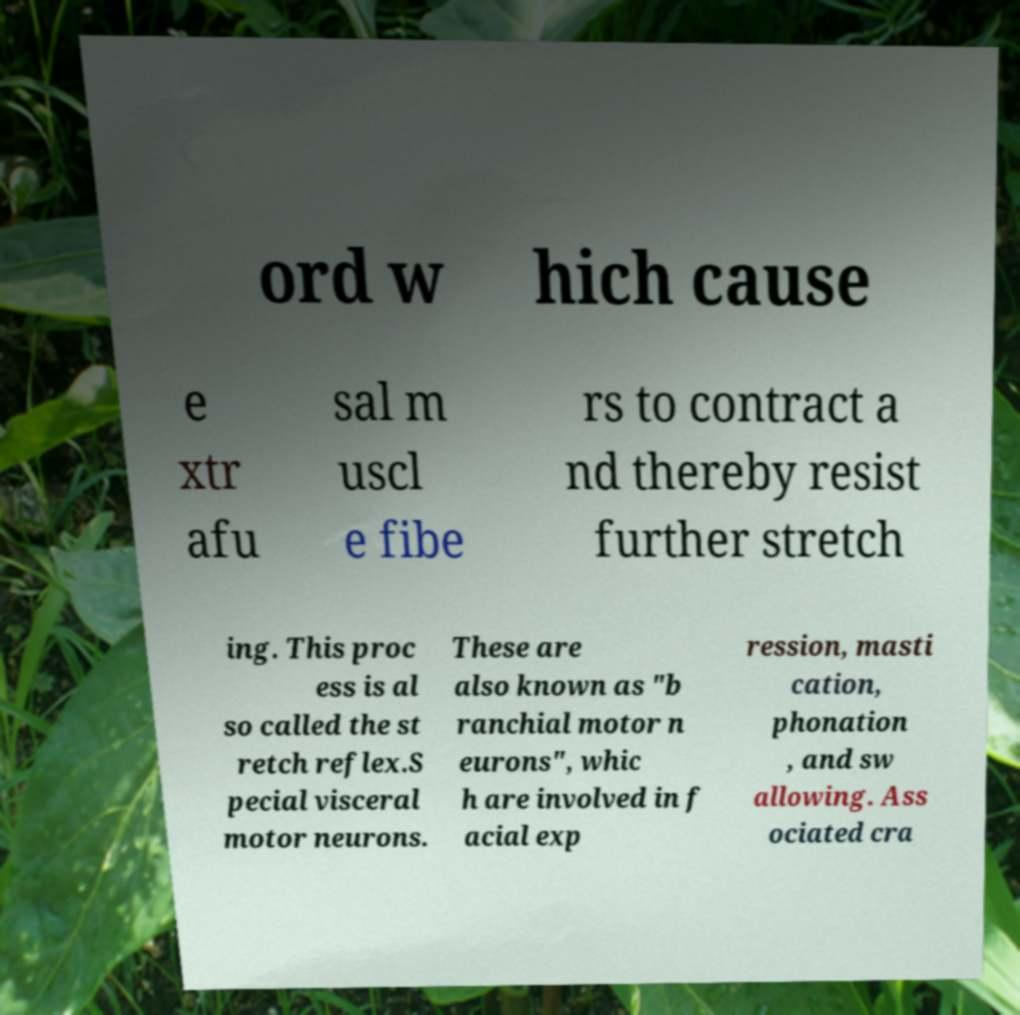I need the written content from this picture converted into text. Can you do that? ord w hich cause e xtr afu sal m uscl e fibe rs to contract a nd thereby resist further stretch ing. This proc ess is al so called the st retch reflex.S pecial visceral motor neurons. These are also known as "b ranchial motor n eurons", whic h are involved in f acial exp ression, masti cation, phonation , and sw allowing. Ass ociated cra 